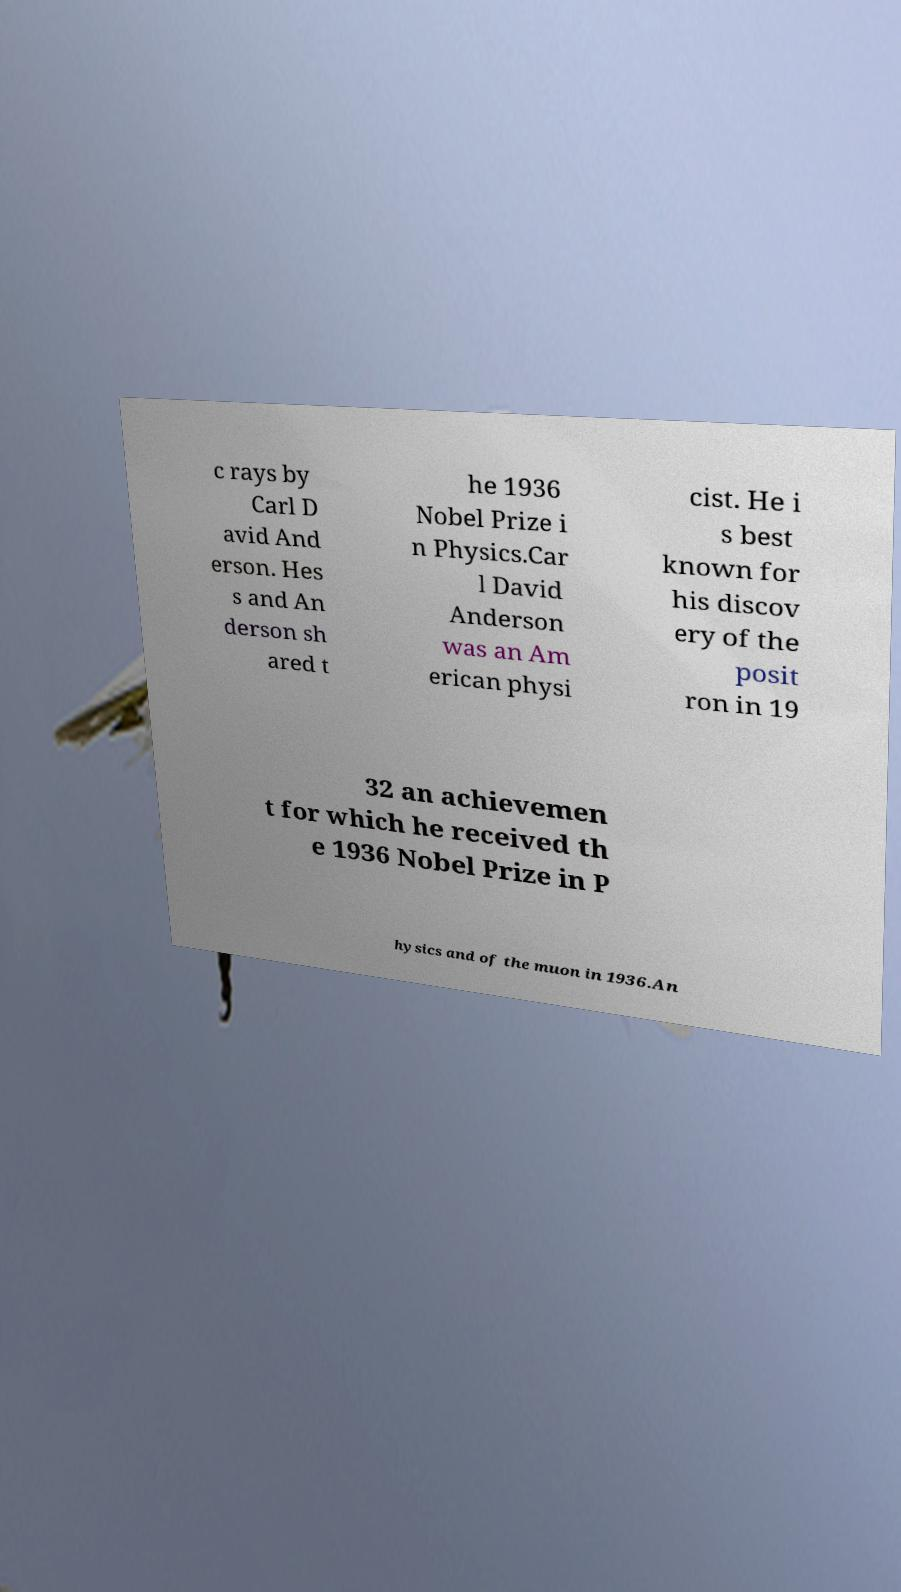For documentation purposes, I need the text within this image transcribed. Could you provide that? c rays by Carl D avid And erson. Hes s and An derson sh ared t he 1936 Nobel Prize i n Physics.Car l David Anderson was an Am erican physi cist. He i s best known for his discov ery of the posit ron in 19 32 an achievemen t for which he received th e 1936 Nobel Prize in P hysics and of the muon in 1936.An 